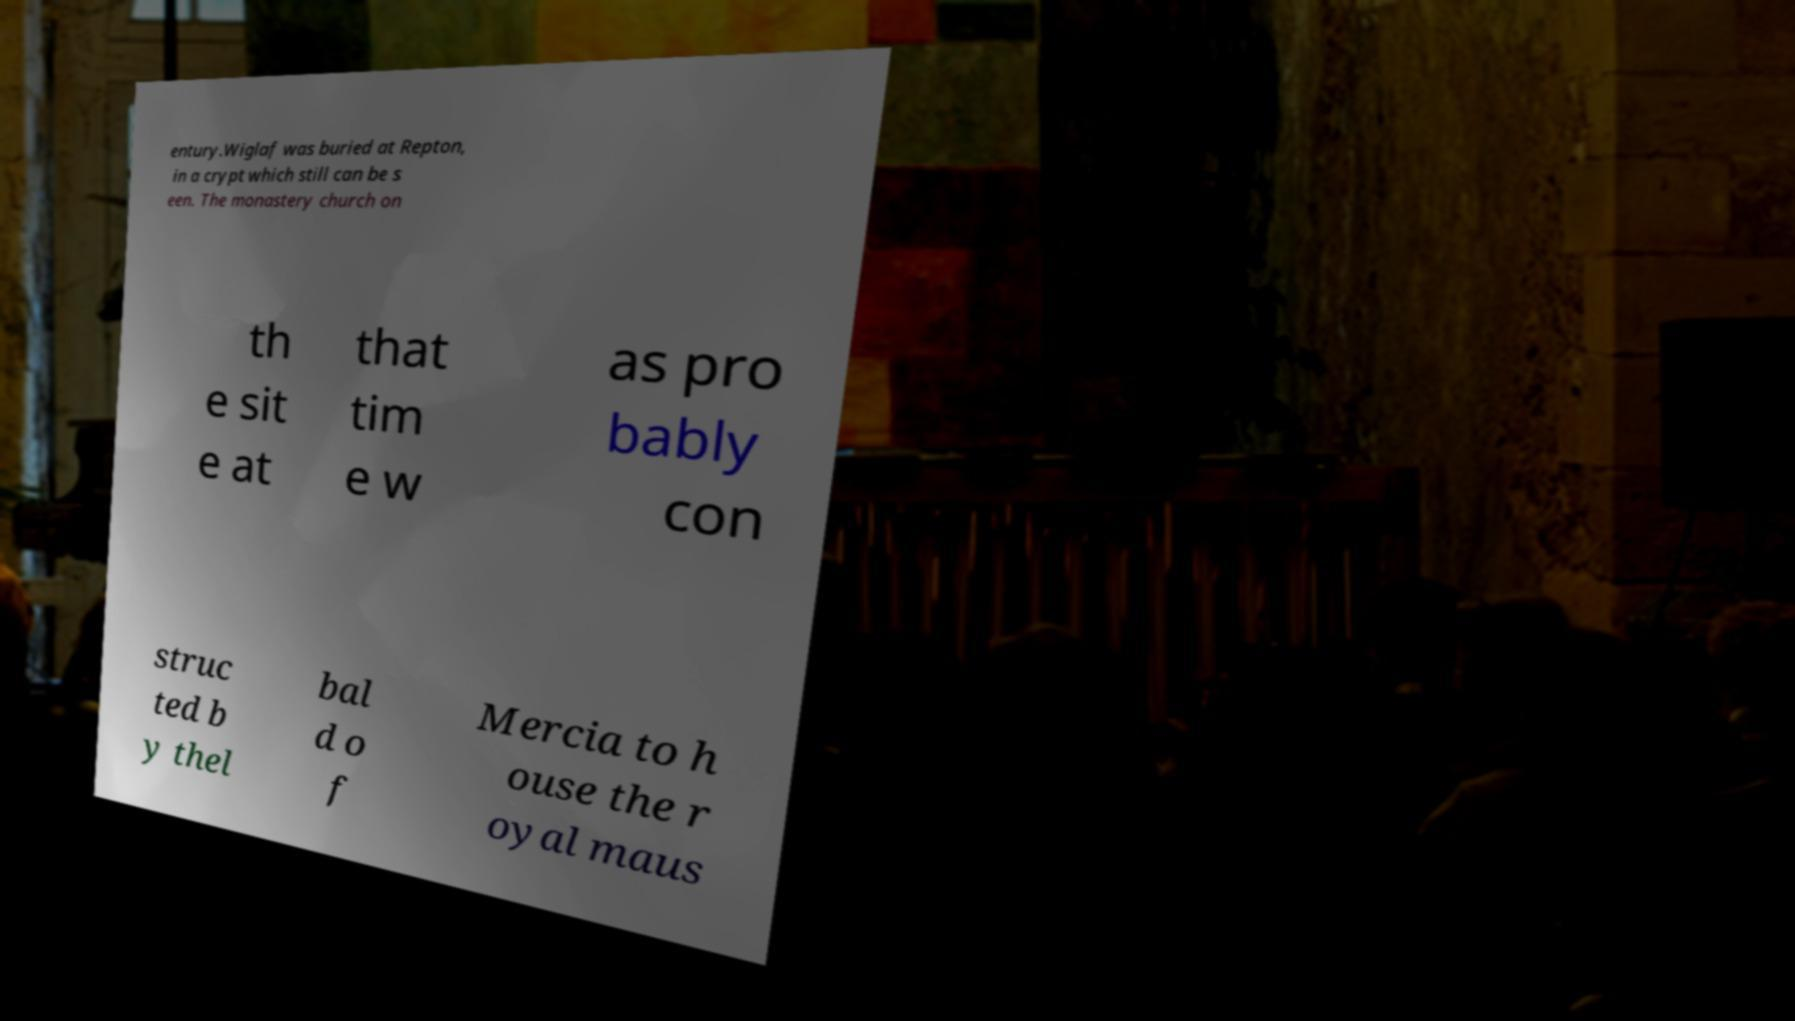For documentation purposes, I need the text within this image transcribed. Could you provide that? entury.Wiglaf was buried at Repton, in a crypt which still can be s een. The monastery church on th e sit e at that tim e w as pro bably con struc ted b y thel bal d o f Mercia to h ouse the r oyal maus 